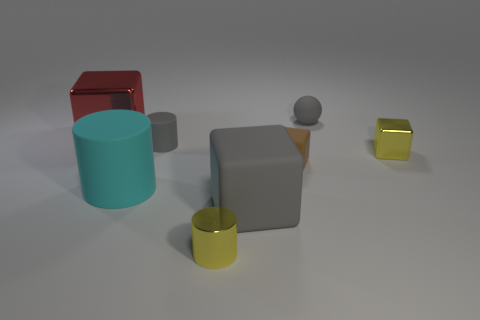What kind of mood or atmosphere does the image evoke? The image evokes a tranquil and clean mood, with the orderly arrangement of objects and the neutral background contributing to a sense of minimalism and balance. 